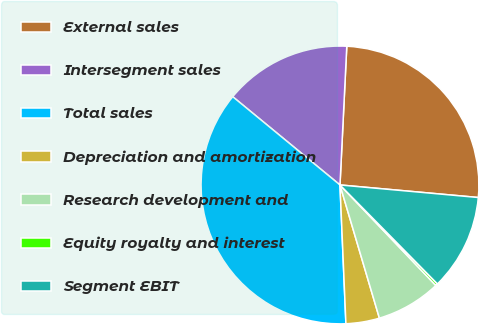Convert chart. <chart><loc_0><loc_0><loc_500><loc_500><pie_chart><fcel>External sales<fcel>Intersegment sales<fcel>Total sales<fcel>Depreciation and amortization<fcel>Research development and<fcel>Equity royalty and interest<fcel>Segment EBIT<nl><fcel>25.66%<fcel>14.82%<fcel>36.64%<fcel>3.9%<fcel>7.54%<fcel>0.26%<fcel>11.18%<nl></chart> 